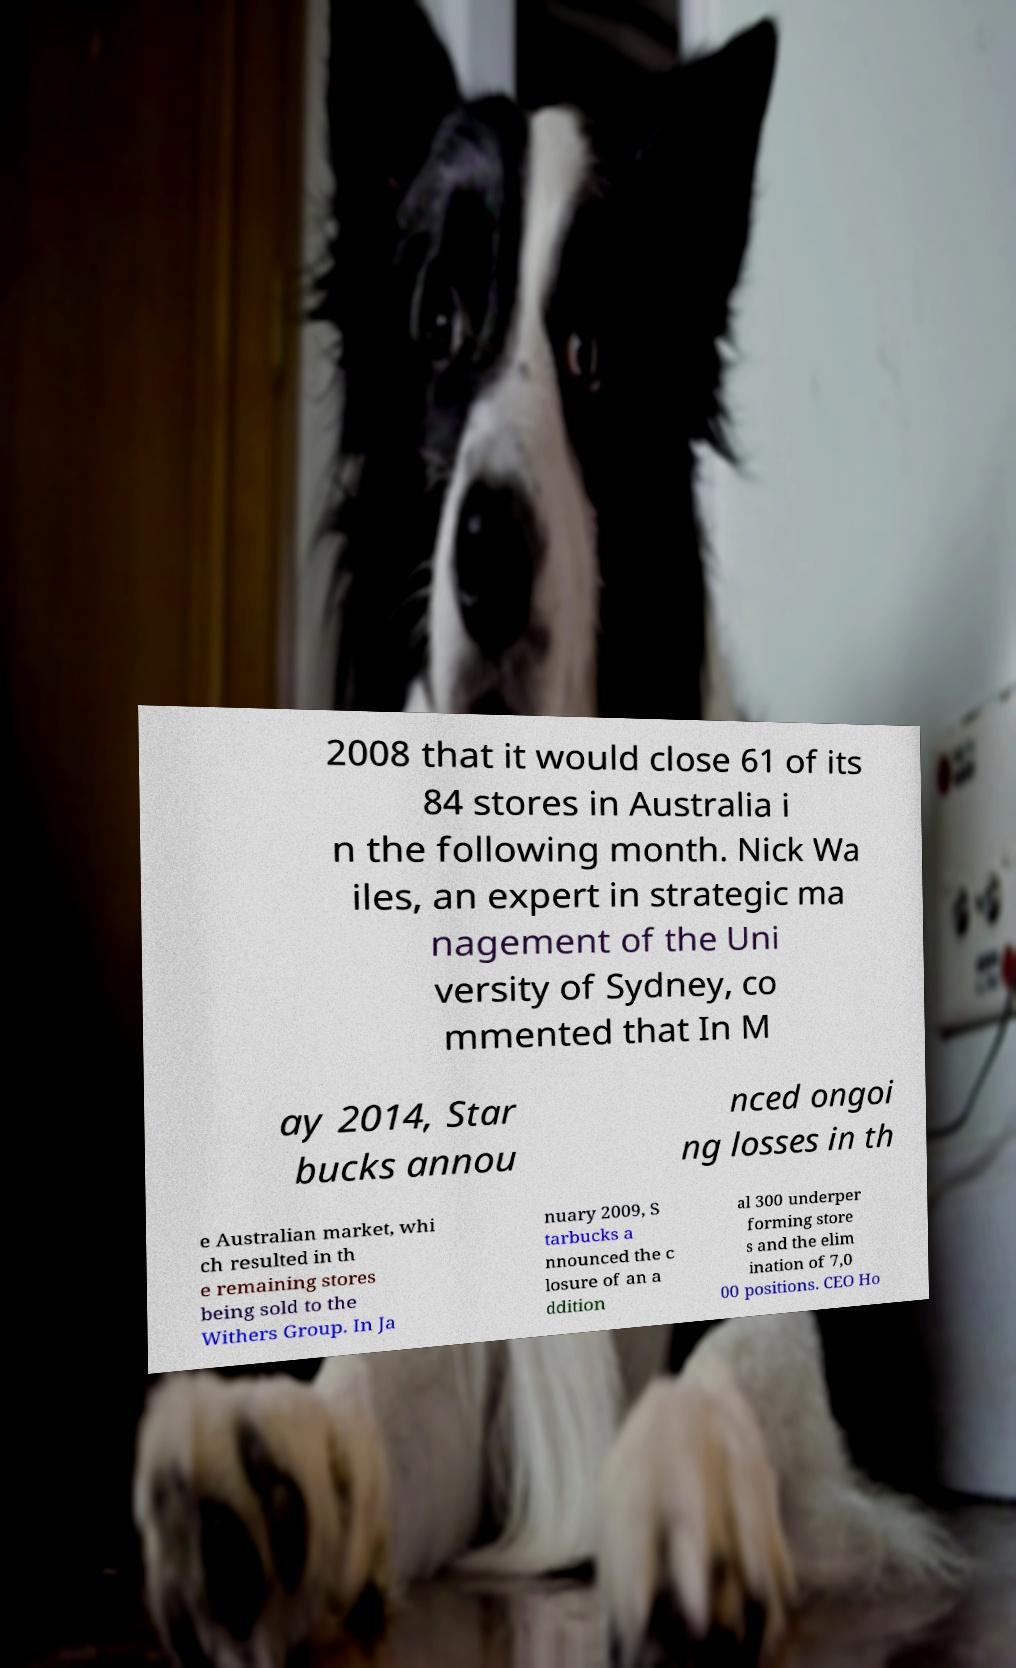I need the written content from this picture converted into text. Can you do that? 2008 that it would close 61 of its 84 stores in Australia i n the following month. Nick Wa iles, an expert in strategic ma nagement of the Uni versity of Sydney, co mmented that In M ay 2014, Star bucks annou nced ongoi ng losses in th e Australian market, whi ch resulted in th e remaining stores being sold to the Withers Group. In Ja nuary 2009, S tarbucks a nnounced the c losure of an a ddition al 300 underper forming store s and the elim ination of 7,0 00 positions. CEO Ho 